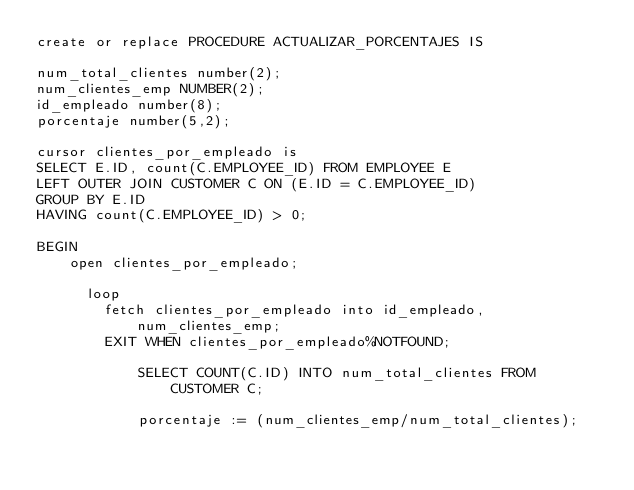Convert code to text. <code><loc_0><loc_0><loc_500><loc_500><_SQL_>create or replace PROCEDURE ACTUALIZAR_PORCENTAJES IS

num_total_clientes number(2);
num_clientes_emp NUMBER(2);
id_empleado number(8);
porcentaje number(5,2);

cursor clientes_por_empleado is
SELECT E.ID, count(C.EMPLOYEE_ID) FROM EMPLOYEE E
LEFT OUTER JOIN CUSTOMER C ON (E.ID = C.EMPLOYEE_ID)
GROUP BY E.ID
HAVING count(C.EMPLOYEE_ID) > 0;

BEGIN
    open clientes_por_empleado;
    
      loop
        fetch clientes_por_empleado into id_empleado, num_clientes_emp;
        EXIT WHEN clientes_por_empleado%NOTFOUND; 
        
            SELECT COUNT(C.ID) INTO num_total_clientes FROM CUSTOMER C;
            
            porcentaje := (num_clientes_emp/num_total_clientes);</code> 